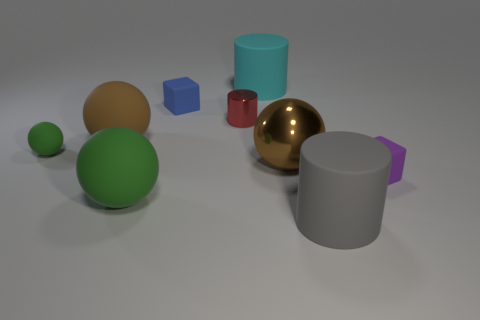There is another ball that is the same color as the large metallic ball; what material is it?
Offer a very short reply. Rubber. Is the big brown object that is on the left side of the shiny ball made of the same material as the red cylinder?
Your answer should be compact. No. What is the shape of the big matte object that is in front of the large green ball?
Offer a terse response. Cylinder. What number of things have the same size as the gray cylinder?
Make the answer very short. 4. What size is the brown metal thing?
Ensure brevity in your answer.  Large. How many blue cubes are behind the cyan rubber thing?
Give a very brief answer. 0. There is a big brown thing that is made of the same material as the small blue thing; what shape is it?
Offer a terse response. Sphere. Are there fewer big brown metal things on the right side of the small purple object than matte cylinders in front of the tiny blue block?
Provide a short and direct response. Yes. Is the number of purple blocks greater than the number of large blue rubber balls?
Offer a very short reply. Yes. What material is the red thing?
Make the answer very short. Metal. 